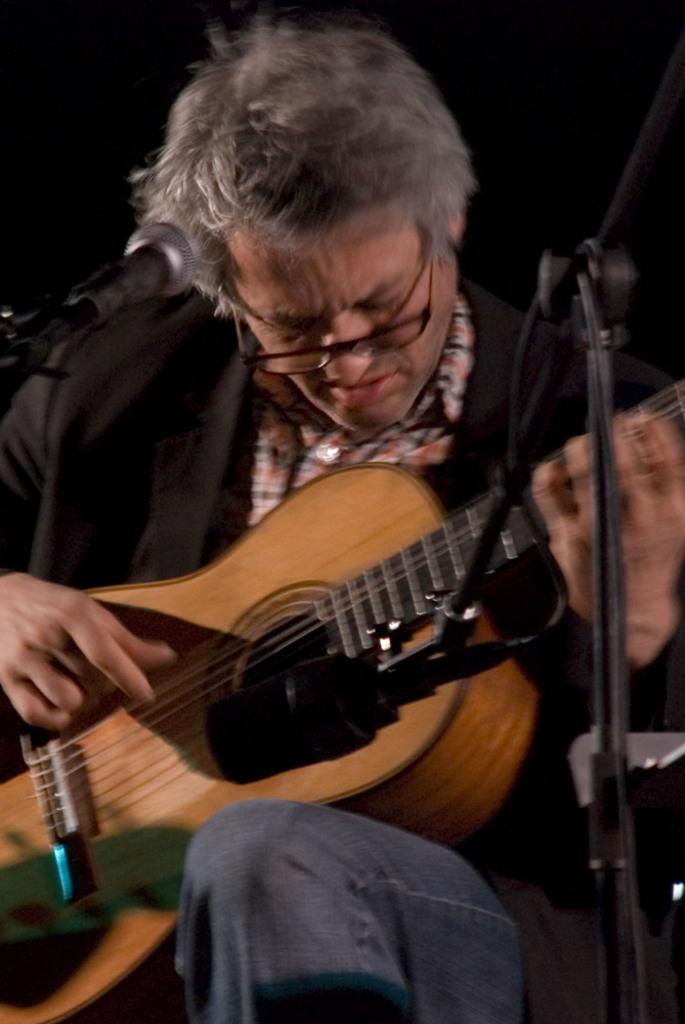Who is the main subject in the image? There is a man in the image. What is the man wearing? The man is wearing a black jacket and blue jeans. Are there any accessories visible on the man? Yes, the man is wearing spectacles. What is the man holding in the image? The man is holding a guitar. What is the man doing with the guitar? The man is playing the guitar. What object is in front of the man? There is a microphone in front of the man. What direction is the man facing in the image? The provided facts do not mention the direction the man is facing, so it cannot be determined from the image. How many children are present in the image? There are no children present in the image; it features a man playing a guitar. 